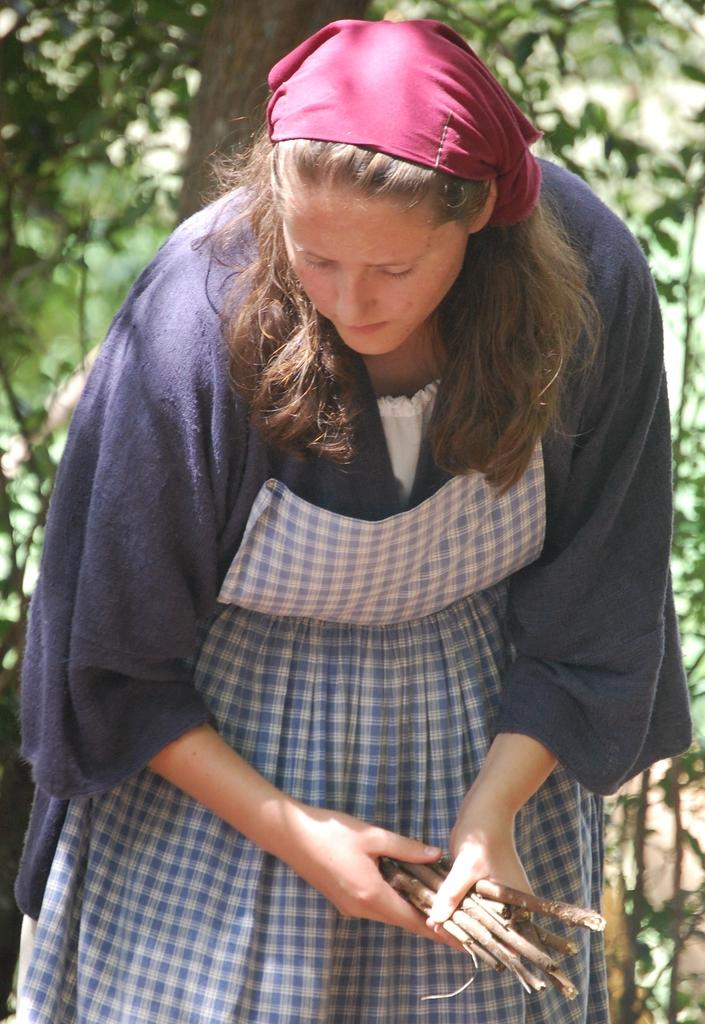Who is present in the image? There is a woman in the image. What is the woman holding in the image? The woman is holding twigs. What can be seen in the background of the image? There are trees in the background of the image. What type of thread is the woman using to sort the brush in the image? There is no thread or brush present in the image; the woman is holding twigs. 